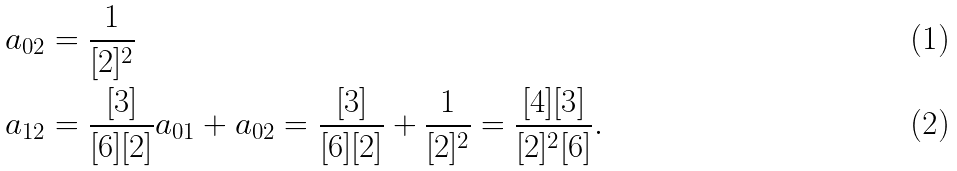Convert formula to latex. <formula><loc_0><loc_0><loc_500><loc_500>a _ { 0 2 } & = \frac { 1 } { [ 2 ] ^ { 2 } } \\ a _ { 1 2 } & = \frac { [ 3 ] } { [ 6 ] [ 2 ] } a _ { 0 1 } + a _ { 0 2 } = \frac { [ 3 ] } { [ 6 ] [ 2 ] } + \frac { 1 } { [ 2 ] ^ { 2 } } = \frac { [ 4 ] [ 3 ] } { [ 2 ] ^ { 2 } [ 6 ] } .</formula> 